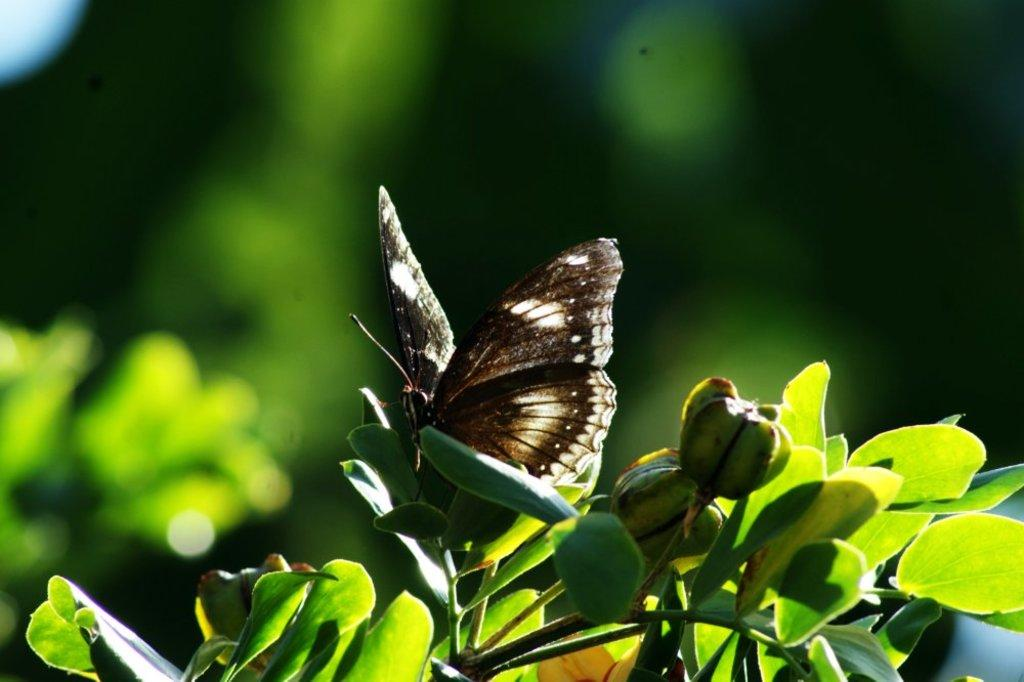What is on the leaf in the image? There is a butterfly on a leaf in the image. What can be seen in the background of the image? There are trees and plants in the background of the image. How many tickets does the butterfly have in the image? There are no tickets present in the image; it features a butterfly on a leaf and trees and plants in the background. 